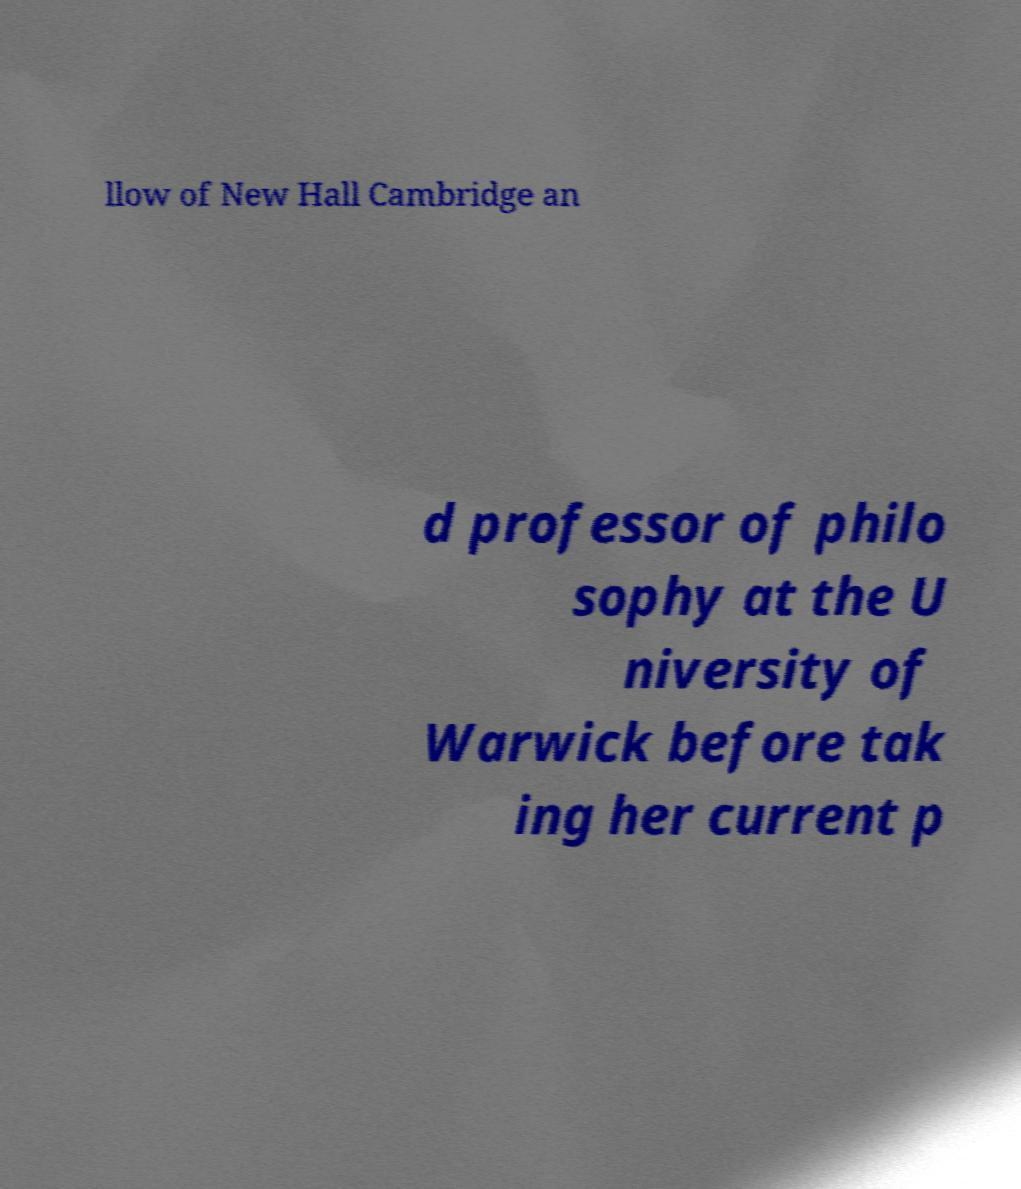What messages or text are displayed in this image? I need them in a readable, typed format. llow of New Hall Cambridge an d professor of philo sophy at the U niversity of Warwick before tak ing her current p 